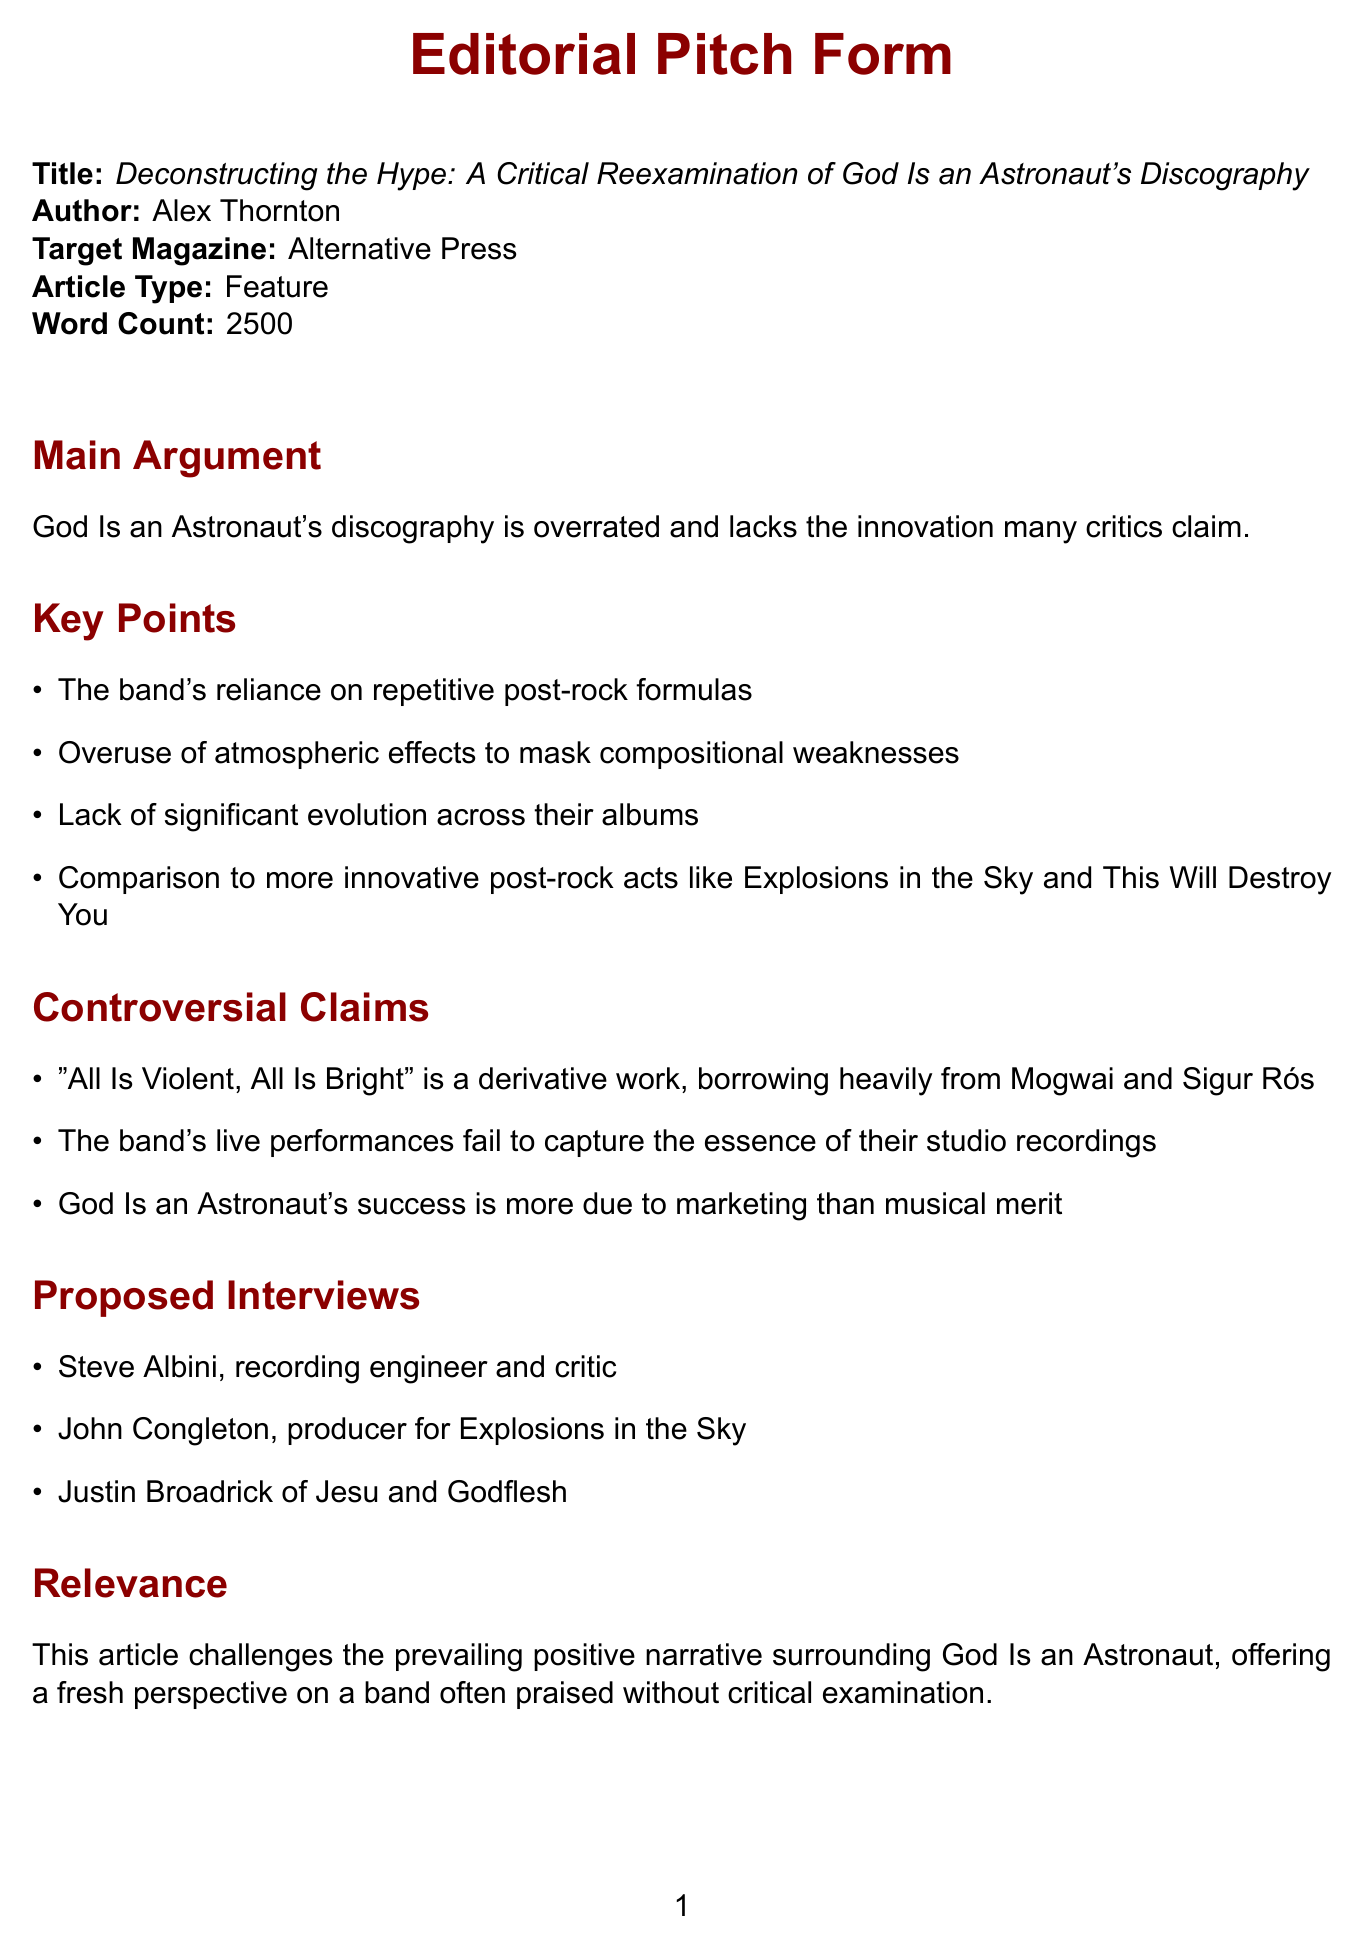What is the title of the article? The title of the article is presented in the document as the main focus area.
Answer: Deconstructing the Hype: A Critical Reexamination of God Is an Astronaut's Discography Who is the author of the pitch? The document explicitly lists the author's name in the introduction section.
Answer: Alex Thornton What is the word count of the article? The document states a predetermined length for the article, indicating its detail and depth.
Answer: 2500 Which magazine is the target for the pitch? The target magazine is specified as part of the article introduction.
Answer: Alternative Press What is one of the controversial claims made in the pitch? The document lists multiple controversial claims made about the band's discography.
Answer: "All Is Violent, All Is Bright" is a derivative work, borrowing heavily from Mogwai and Sigur Rós What is the main argument of the article? The document summarizes the essence of the article's viewpoint in a clear statement.
Answer: God Is an Astronaut's discography is overrated and lacks the innovation many critics claim Which band is compared to God Is an Astronaut in terms of innovation? The document includes a comparison to other notable acts in the post-rock genre to support its arguments.
Answer: Explosions in the Sky What type of visual element is proposed for the article? The document outlines specific visual elements intended to enhance reader engagement and understanding.
Answer: Infographic comparing God Is an Astronaut's album ratings to other post-rock bands 